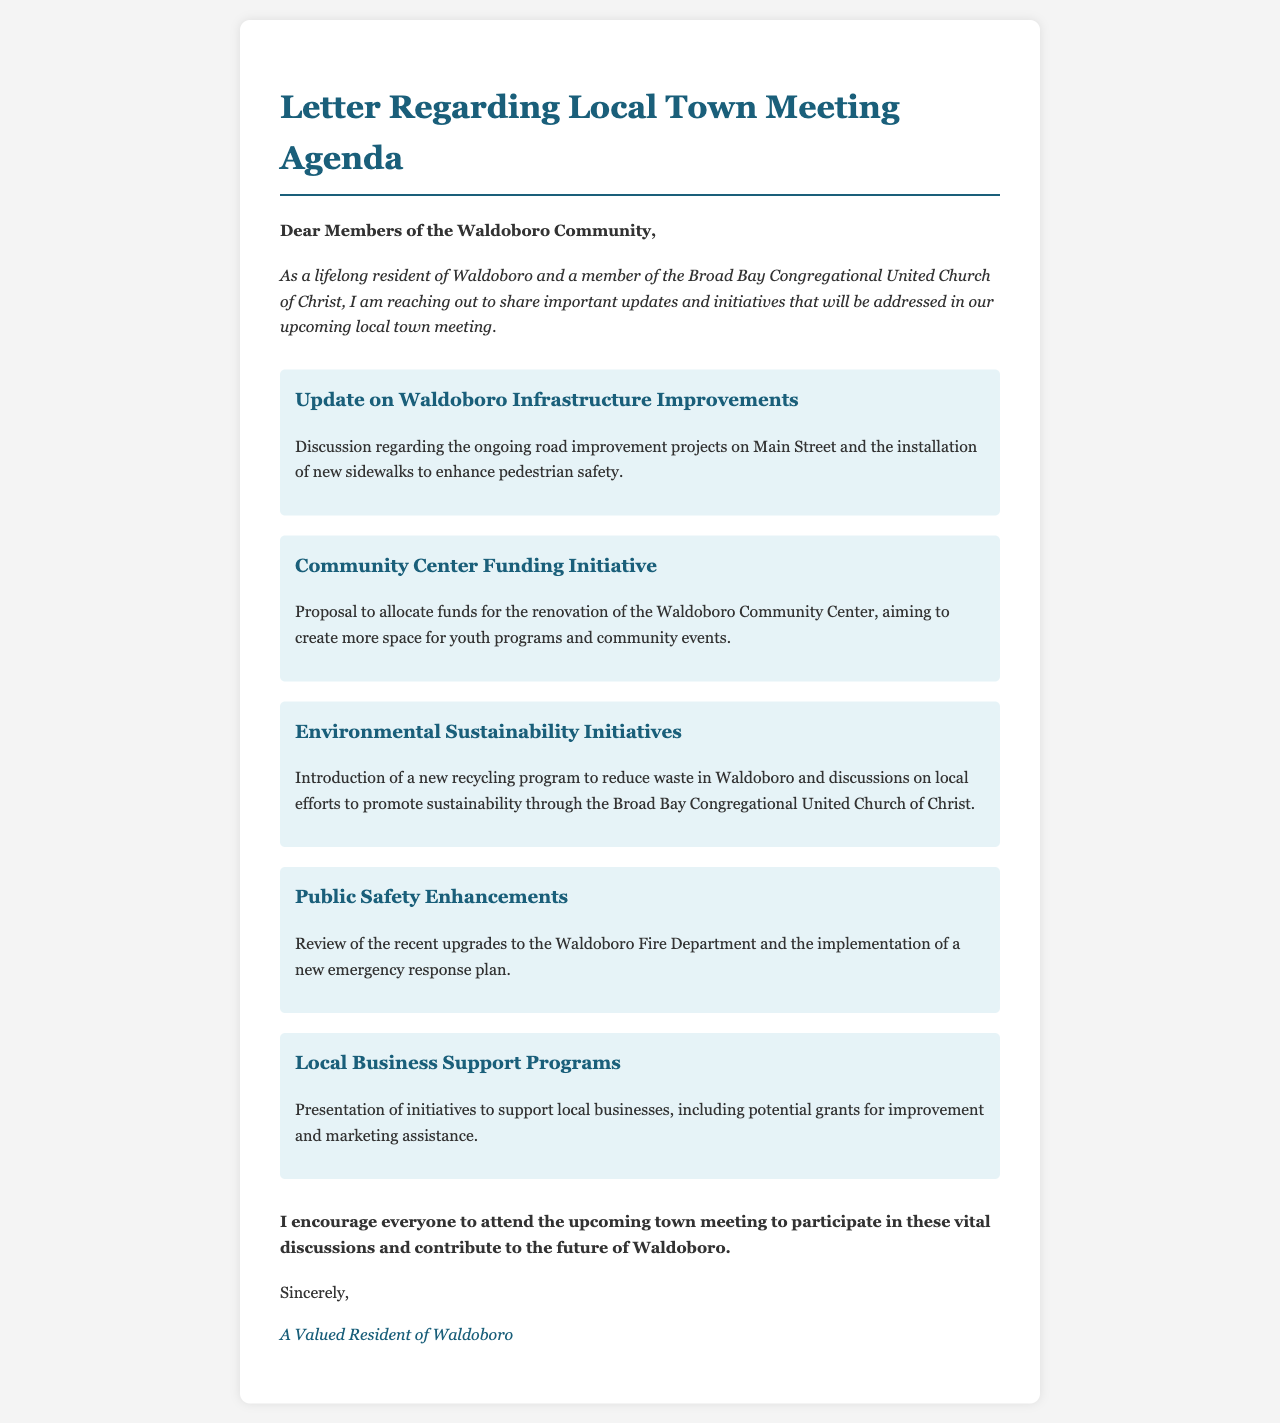What is the title of the letter? The title is stated at the beginning of the document, which describes the topic of the letter.
Answer: Letter Regarding Local Town Meeting Agenda Who wrote the letter? The letter is signed by a resident of Waldoboro, representing their perspective in the community.
Answer: A Valued Resident of Waldoboro What community initiative focuses on pedestrian safety? This initiative is mentioned as part of the agenda regarding infrastructure improvements.
Answer: Update on Waldoboro Infrastructure Improvements What is proposed for the Waldoboro Community Center? The document includes a specific proposal aimed at enhancing the community space.
Answer: Renovation of the Waldoboro Community Center Which organization is mentioned in relation to environmental initiatives? This organization is highlighted in the context of promoting sustainability efforts.
Answer: Broad Bay Congregational United Church of Christ How many agenda items are listed in the document? The total number of distinct agenda items can be counted to answer this question.
Answer: Five What is a key focus of the Public Safety Enhancements agenda item? This item includes discussion on specific upgrades aimed at improving safety.
Answer: Upgrades to the Waldoboro Fire Department What is the conclusion of the letter? The conclusion expresses a call to action for community involvement in the upcoming meeting.
Answer: Attend the upcoming town meeting 